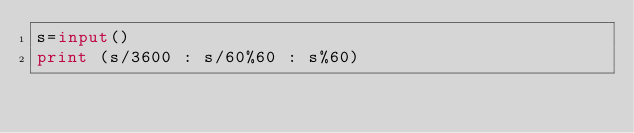Convert code to text. <code><loc_0><loc_0><loc_500><loc_500><_Python_>s=input()
print (s/3600 : s/60%60 : s%60)
</code> 